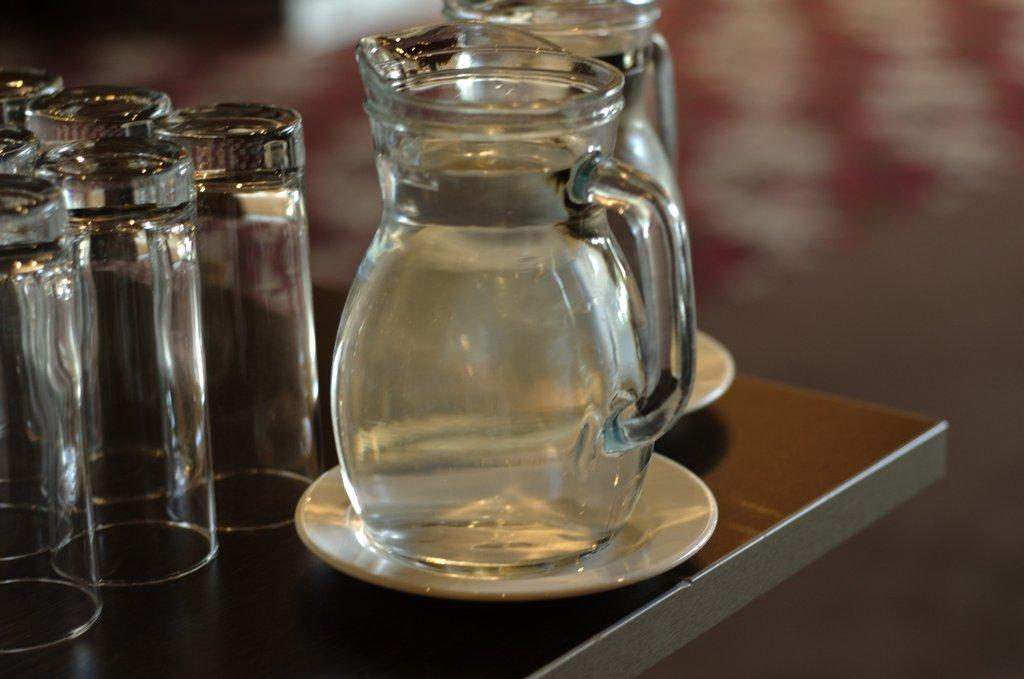What piece of furniture is present in the image? There is a table in the image. What objects are placed on the table? There are two jars on the table, each on a saucer. What might be used to hold the jars in place on the table? The saucers are used to hold the jars in place on the table. What other items are near the jars and saucers? There are glasses beside the jars and saucers. What type of milk is being poured into the jars in the image? There is no milk present in the image; it only shows two jars on a table, each on a saucer, with glasses beside them. Can you see a toothbrush in the image? No, there is no toothbrush present in the image. 